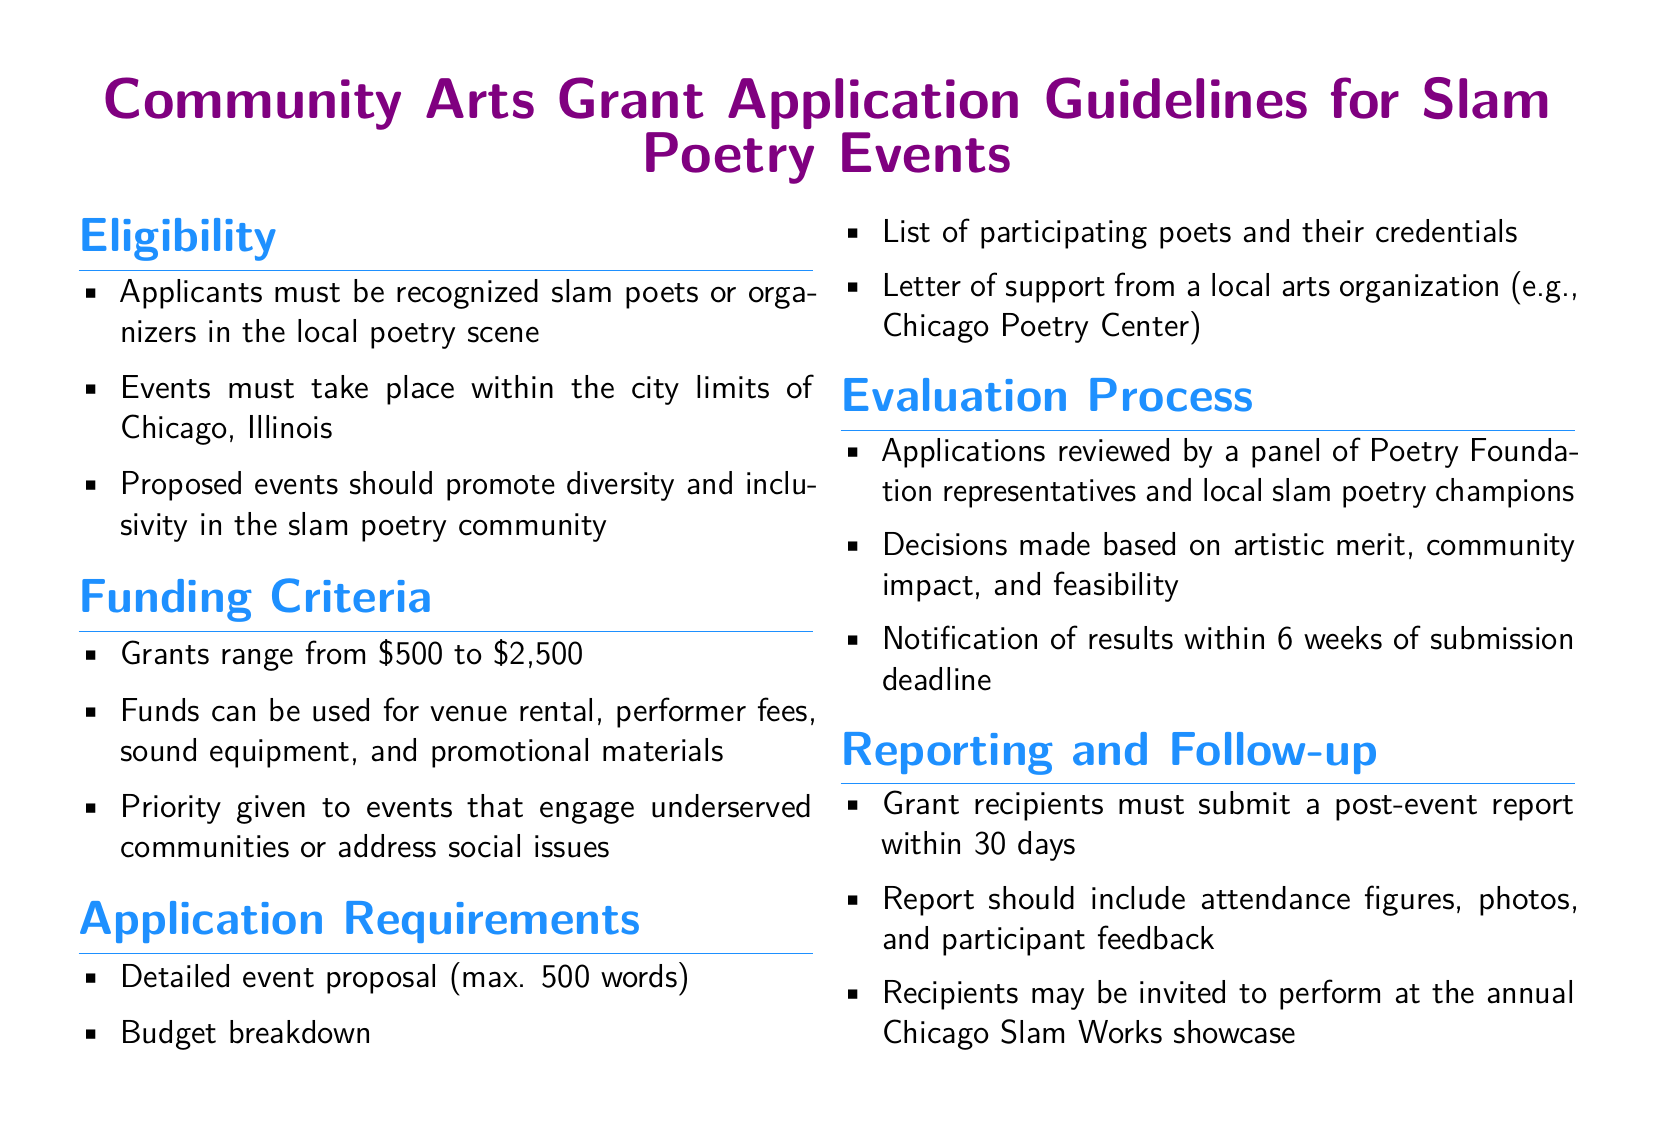What are the residency requirements for applicants? The eligibility section states that applicants must be recognized slam poets or organizers in the local poetry scene in Chicago, Illinois.
Answer: Chicago, Illinois What is the minimum grant amount available? The funding criteria section specifies that grants range from $500 to $2,500, with $500 being the minimum.
Answer: $500 What is the maximum word count for the event proposal? The application requirements detail that the event proposal should be a maximum of 500 words.
Answer: 500 words Who reviews the applications? The evaluation process section indicates that applications will be reviewed by a panel of Poetry Foundation representatives and local slam poetry champions.
Answer: Poetry Foundation representatives and local slam poetry champions When will applicants be notified of the results? According to the evaluation process, applicants can expect to be notified of results within 6 weeks of the submission deadline.
Answer: 6 weeks What types of expenses can grant funds be used for? The funding criteria outlines that funds can be used for venue rental, performer fees, sound equipment, and promotional materials.
Answer: Venue rental, performer fees, sound equipment, promotional materials What is included in the post-event report for grant recipients? The reporting and follow-up section explains that the report should include attendance figures, photos, and participant feedback.
Answer: Attendance figures, photos, participant feedback Which community values should events promote? The eligibility section highlights the importance of events promoting diversity and inclusivity in the slam poetry community.
Answer: Diversity and inclusivity What is a priority criterion for funding consideration? The funding criteria states that priority is given to events that engage underserved communities or address social issues.
Answer: Underserved communities or social issues 